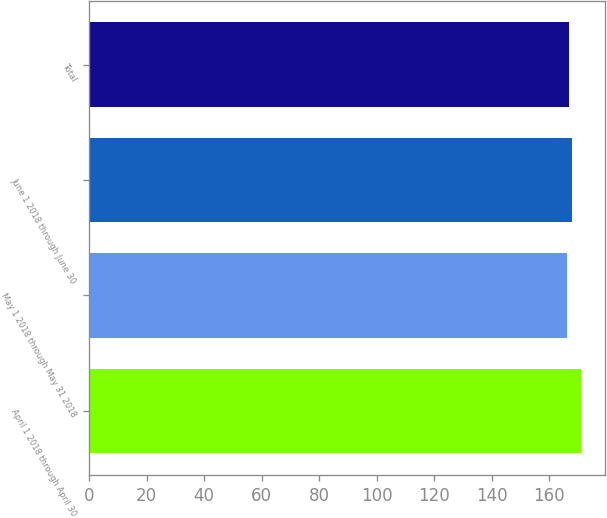Convert chart. <chart><loc_0><loc_0><loc_500><loc_500><bar_chart><fcel>April 1 2018 through April 30<fcel>May 1 2018 through May 31 2018<fcel>June 1 2018 through June 30<fcel>Total<nl><fcel>170.96<fcel>166.21<fcel>168.11<fcel>166.92<nl></chart> 